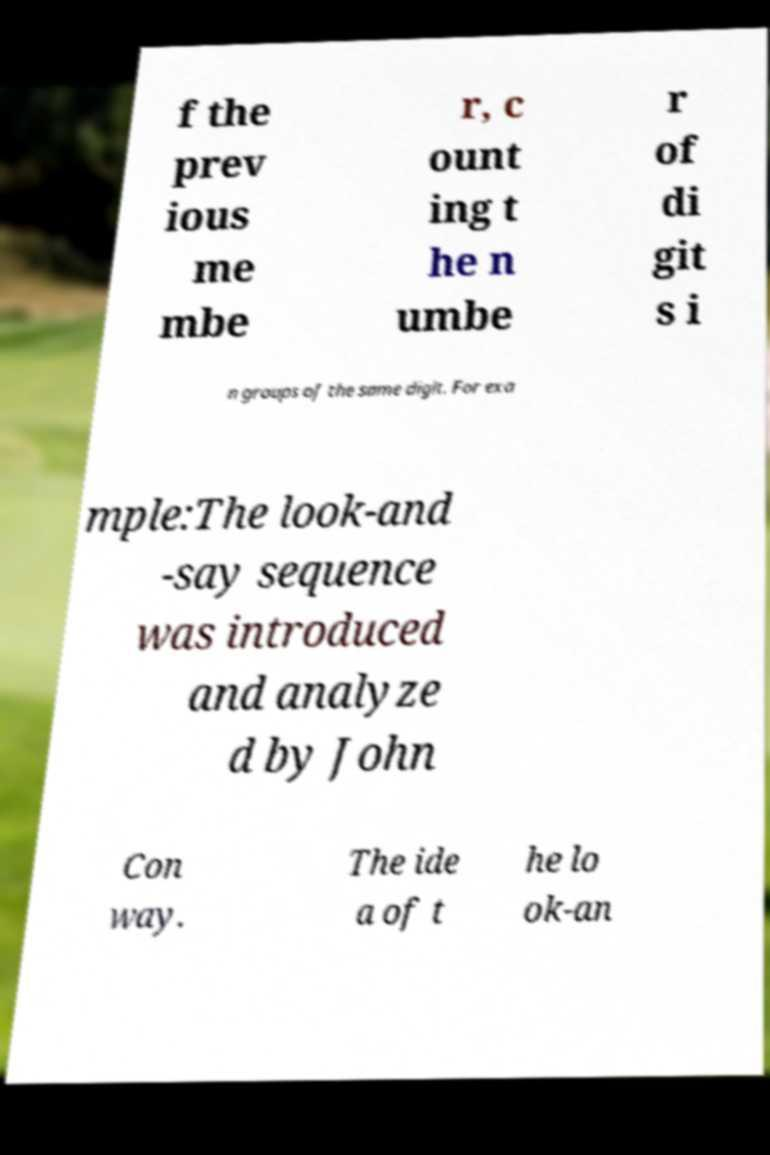What messages or text are displayed in this image? I need them in a readable, typed format. f the prev ious me mbe r, c ount ing t he n umbe r of di git s i n groups of the same digit. For exa mple:The look-and -say sequence was introduced and analyze d by John Con way. The ide a of t he lo ok-an 